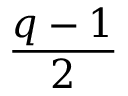Convert formula to latex. <formula><loc_0><loc_0><loc_500><loc_500>\frac { q - 1 } { 2 }</formula> 